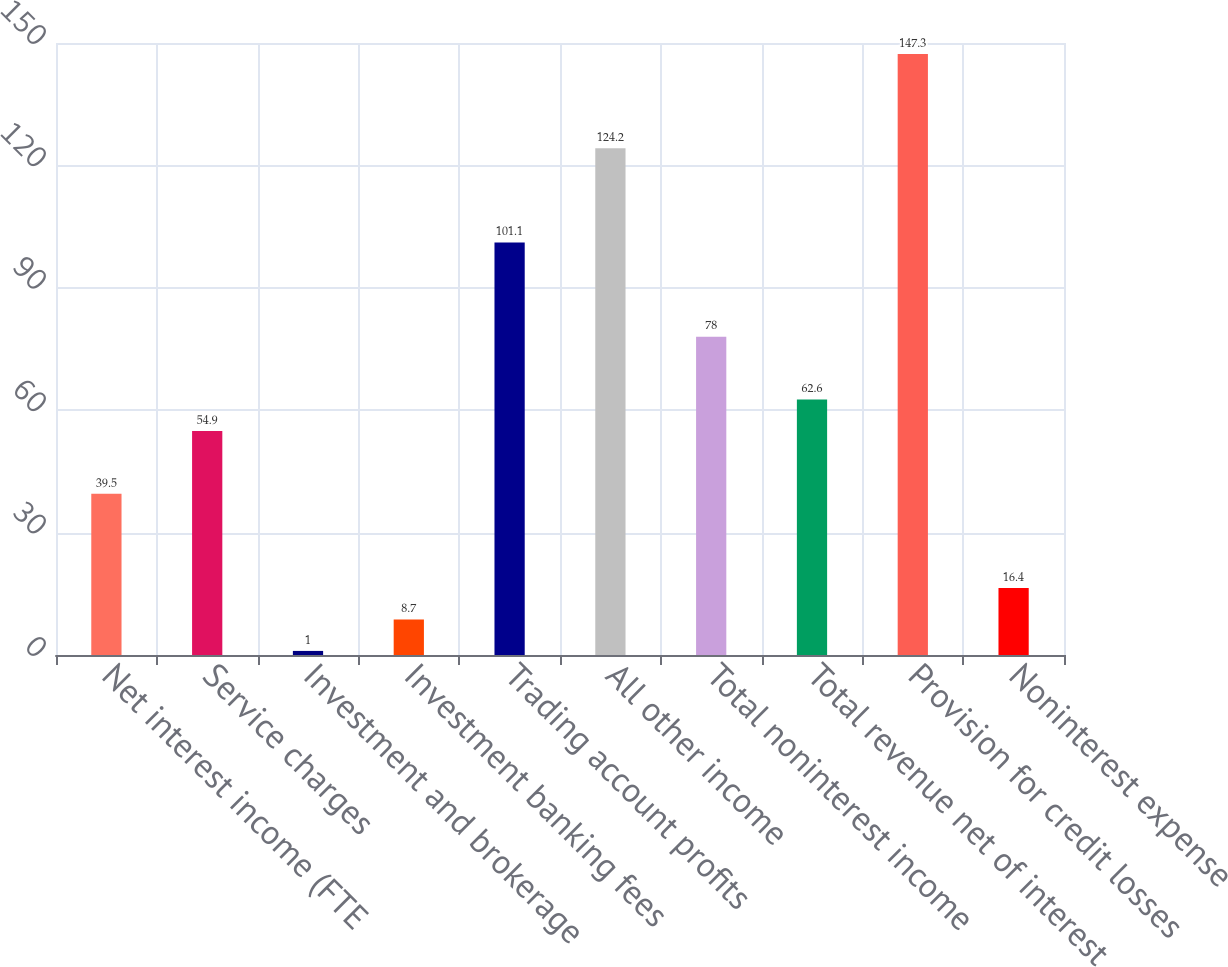Convert chart to OTSL. <chart><loc_0><loc_0><loc_500><loc_500><bar_chart><fcel>Net interest income (FTE<fcel>Service charges<fcel>Investment and brokerage<fcel>Investment banking fees<fcel>Trading account profits<fcel>All other income<fcel>Total noninterest income<fcel>Total revenue net of interest<fcel>Provision for credit losses<fcel>Noninterest expense<nl><fcel>39.5<fcel>54.9<fcel>1<fcel>8.7<fcel>101.1<fcel>124.2<fcel>78<fcel>62.6<fcel>147.3<fcel>16.4<nl></chart> 